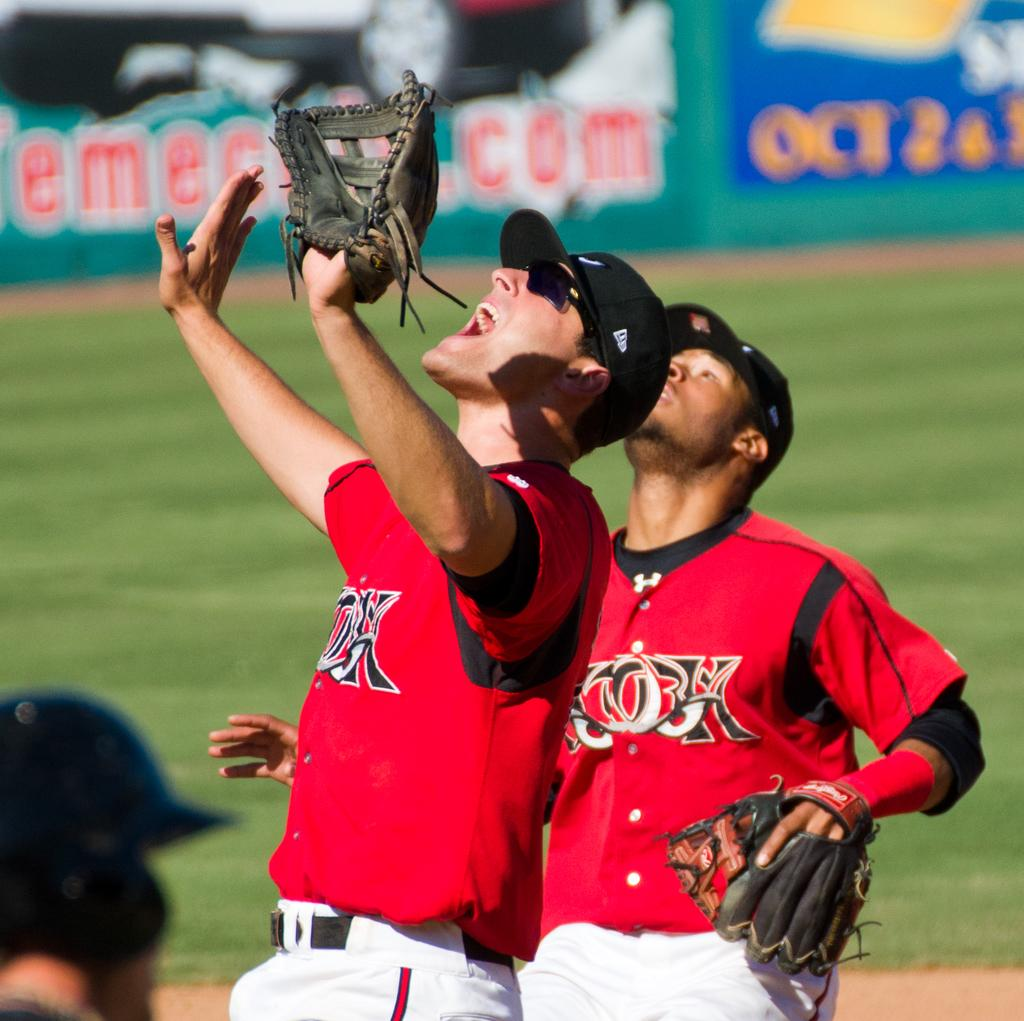<image>
Create a compact narrative representing the image presented. Two baseball players on the same team are looking up trying to catch a ball while in the background there is an announcement for Oct 2 & 3. 